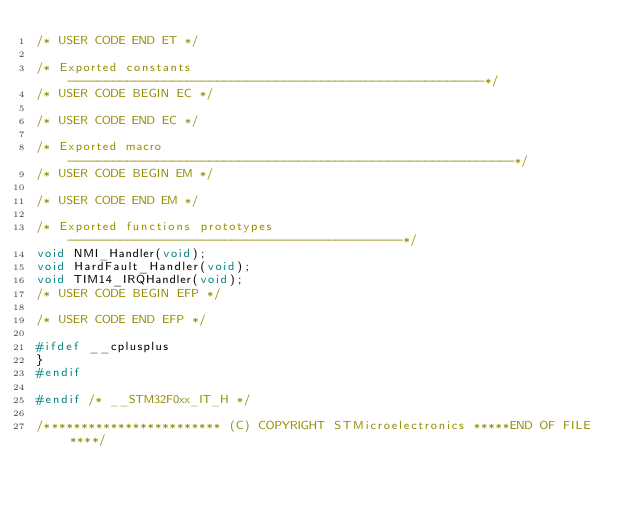<code> <loc_0><loc_0><loc_500><loc_500><_C_>/* USER CODE END ET */

/* Exported constants --------------------------------------------------------*/
/* USER CODE BEGIN EC */

/* USER CODE END EC */

/* Exported macro ------------------------------------------------------------*/
/* USER CODE BEGIN EM */

/* USER CODE END EM */

/* Exported functions prototypes ---------------------------------------------*/
void NMI_Handler(void);
void HardFault_Handler(void);
void TIM14_IRQHandler(void);
/* USER CODE BEGIN EFP */

/* USER CODE END EFP */

#ifdef __cplusplus
}
#endif

#endif /* __STM32F0xx_IT_H */

/************************ (C) COPYRIGHT STMicroelectronics *****END OF FILE****/
</code> 